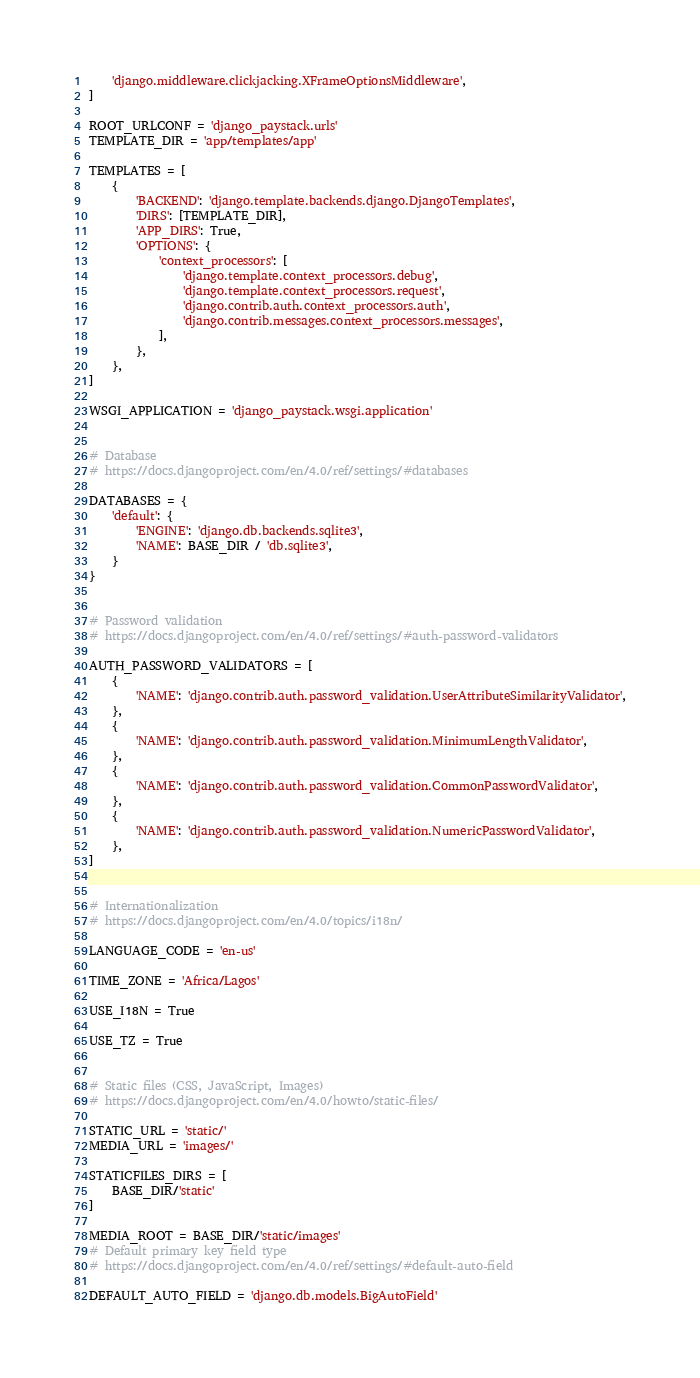<code> <loc_0><loc_0><loc_500><loc_500><_Python_>    'django.middleware.clickjacking.XFrameOptionsMiddleware',
]

ROOT_URLCONF = 'django_paystack.urls'
TEMPLATE_DIR = 'app/templates/app'

TEMPLATES = [
    {
        'BACKEND': 'django.template.backends.django.DjangoTemplates',
        'DIRS': [TEMPLATE_DIR],
        'APP_DIRS': True,
        'OPTIONS': {
            'context_processors': [
                'django.template.context_processors.debug',
                'django.template.context_processors.request',
                'django.contrib.auth.context_processors.auth',
                'django.contrib.messages.context_processors.messages',
            ],
        },
    },
]

WSGI_APPLICATION = 'django_paystack.wsgi.application'


# Database
# https://docs.djangoproject.com/en/4.0/ref/settings/#databases

DATABASES = {
    'default': {
        'ENGINE': 'django.db.backends.sqlite3',
        'NAME': BASE_DIR / 'db.sqlite3',
    }
}


# Password validation
# https://docs.djangoproject.com/en/4.0/ref/settings/#auth-password-validators

AUTH_PASSWORD_VALIDATORS = [
    {
        'NAME': 'django.contrib.auth.password_validation.UserAttributeSimilarityValidator',
    },
    {
        'NAME': 'django.contrib.auth.password_validation.MinimumLengthValidator',
    },
    {
        'NAME': 'django.contrib.auth.password_validation.CommonPasswordValidator',
    },
    {
        'NAME': 'django.contrib.auth.password_validation.NumericPasswordValidator',
    },
]


# Internationalization
# https://docs.djangoproject.com/en/4.0/topics/i18n/

LANGUAGE_CODE = 'en-us'

TIME_ZONE = 'Africa/Lagos'

USE_I18N = True

USE_TZ = True


# Static files (CSS, JavaScript, Images)
# https://docs.djangoproject.com/en/4.0/howto/static-files/

STATIC_URL = 'static/'
MEDIA_URL = 'images/'

STATICFILES_DIRS = [
    BASE_DIR/'static'
]

MEDIA_ROOT = BASE_DIR/'static/images'
# Default primary key field type
# https://docs.djangoproject.com/en/4.0/ref/settings/#default-auto-field

DEFAULT_AUTO_FIELD = 'django.db.models.BigAutoField'
</code> 